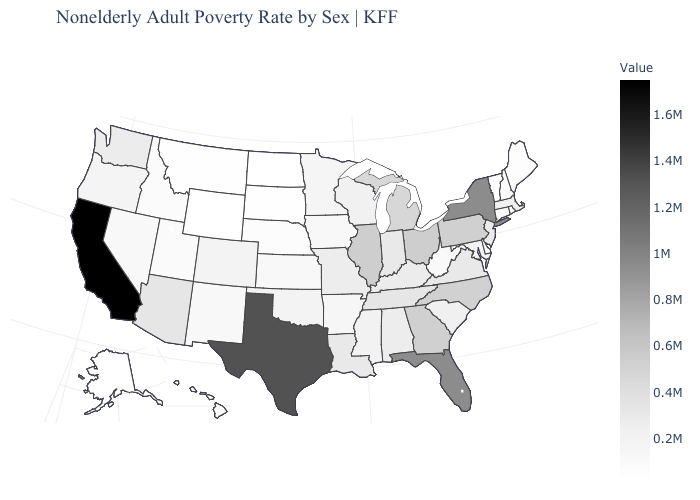Among the states that border Oklahoma , which have the lowest value?
Short answer required. Kansas. Which states hav the highest value in the West?
Write a very short answer. California. Which states have the lowest value in the USA?
Write a very short answer. Wyoming. Which states hav the highest value in the South?
Answer briefly. Texas. Among the states that border New Jersey , which have the highest value?
Answer briefly. New York. Does Alaska have the highest value in the West?
Answer briefly. No. 